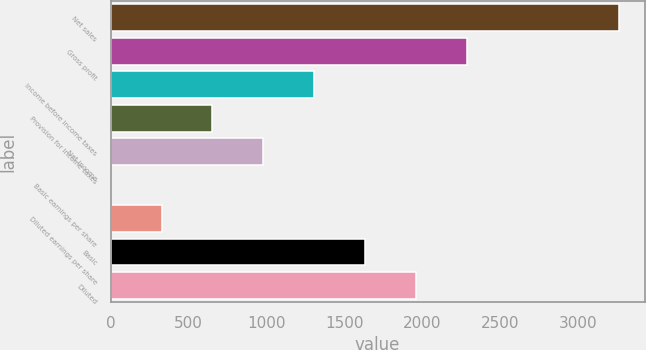<chart> <loc_0><loc_0><loc_500><loc_500><bar_chart><fcel>Net sales<fcel>Gross profit<fcel>Income before income taxes<fcel>Provision for income taxes<fcel>Net income<fcel>Basic earnings per share<fcel>Diluted earnings per share<fcel>Basic<fcel>Diluted<nl><fcel>3262<fcel>2283.45<fcel>1304.91<fcel>652.55<fcel>978.73<fcel>0.19<fcel>326.37<fcel>1631.09<fcel>1957.27<nl></chart> 